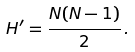<formula> <loc_0><loc_0><loc_500><loc_500>H ^ { \prime } = \frac { N ( N - 1 ) } { 2 } \, .</formula> 